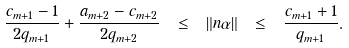<formula> <loc_0><loc_0><loc_500><loc_500>\frac { c _ { m + 1 } - 1 } { 2 q _ { m + 1 } } + \frac { a _ { m + 2 } - c _ { m + 2 } } { 2 q _ { m + 2 } } \ \leq \ \| n \alpha \| \ \leq \ \frac { c _ { m + 1 } + 1 } { q _ { m + 1 } } .</formula> 